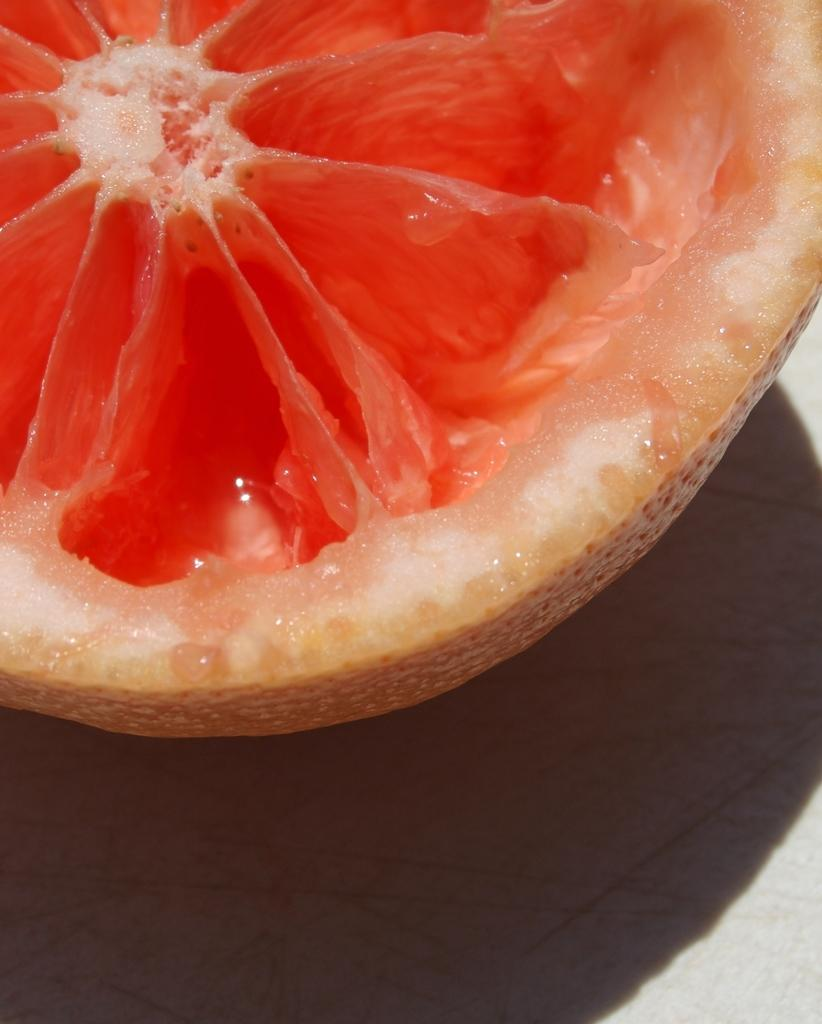What is the main subject of the image? The main subject of the image is a fruit slice. Where is the fruit slice located in the image? The fruit slice is on a surface in the image. What type of garden can be seen in the image? There is no garden present in the image; it features a fruit slice on a surface. What does the fruit slice say in the image? The fruit slice does not have a voice or the ability to speak, so it cannot say anything in the image. 